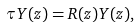Convert formula to latex. <formula><loc_0><loc_0><loc_500><loc_500>\tau Y ( z ) = R ( z ) Y ( z ) ,</formula> 